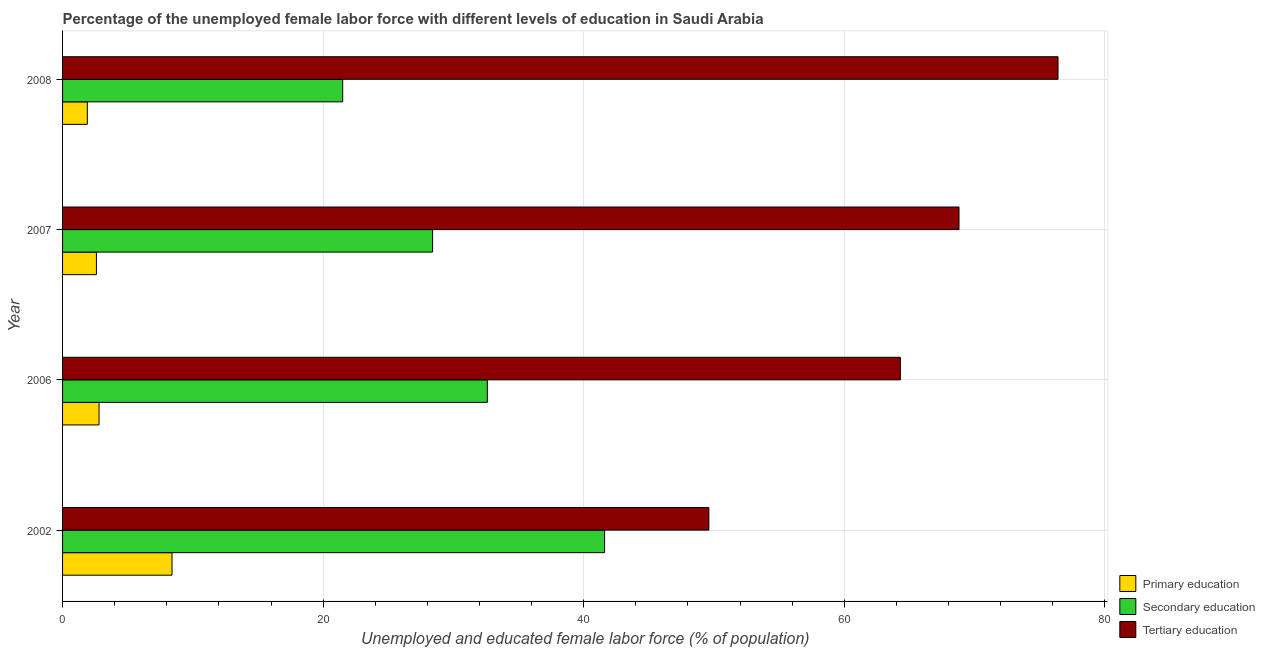How many different coloured bars are there?
Offer a terse response. 3. Are the number of bars on each tick of the Y-axis equal?
Your response must be concise. Yes. How many bars are there on the 2nd tick from the bottom?
Provide a succinct answer. 3. In how many cases, is the number of bars for a given year not equal to the number of legend labels?
Offer a terse response. 0. What is the percentage of female labor force who received tertiary education in 2002?
Your answer should be compact. 49.6. Across all years, what is the maximum percentage of female labor force who received primary education?
Your response must be concise. 8.4. Across all years, what is the minimum percentage of female labor force who received primary education?
Your answer should be very brief. 1.9. In which year was the percentage of female labor force who received primary education minimum?
Your answer should be compact. 2008. What is the total percentage of female labor force who received secondary education in the graph?
Ensure brevity in your answer.  124.1. What is the difference between the percentage of female labor force who received tertiary education in 2002 and that in 2006?
Ensure brevity in your answer.  -14.7. What is the difference between the percentage of female labor force who received secondary education in 2002 and the percentage of female labor force who received primary education in 2006?
Offer a terse response. 38.8. What is the average percentage of female labor force who received secondary education per year?
Give a very brief answer. 31.02. In the year 2006, what is the difference between the percentage of female labor force who received primary education and percentage of female labor force who received tertiary education?
Ensure brevity in your answer.  -61.5. In how many years, is the percentage of female labor force who received primary education greater than 8 %?
Offer a very short reply. 1. What is the ratio of the percentage of female labor force who received primary education in 2006 to that in 2007?
Give a very brief answer. 1.08. Is the percentage of female labor force who received secondary education in 2006 less than that in 2007?
Keep it short and to the point. No. What is the difference between the highest and the lowest percentage of female labor force who received secondary education?
Keep it short and to the point. 20.1. In how many years, is the percentage of female labor force who received primary education greater than the average percentage of female labor force who received primary education taken over all years?
Provide a succinct answer. 1. What does the 2nd bar from the top in 2002 represents?
Ensure brevity in your answer.  Secondary education. What does the 3rd bar from the bottom in 2006 represents?
Provide a succinct answer. Tertiary education. How many bars are there?
Your answer should be very brief. 12. What is the difference between two consecutive major ticks on the X-axis?
Ensure brevity in your answer.  20. Are the values on the major ticks of X-axis written in scientific E-notation?
Provide a succinct answer. No. Does the graph contain any zero values?
Ensure brevity in your answer.  No. What is the title of the graph?
Provide a short and direct response. Percentage of the unemployed female labor force with different levels of education in Saudi Arabia. What is the label or title of the X-axis?
Keep it short and to the point. Unemployed and educated female labor force (% of population). What is the Unemployed and educated female labor force (% of population) of Primary education in 2002?
Provide a short and direct response. 8.4. What is the Unemployed and educated female labor force (% of population) of Secondary education in 2002?
Offer a terse response. 41.6. What is the Unemployed and educated female labor force (% of population) of Tertiary education in 2002?
Provide a short and direct response. 49.6. What is the Unemployed and educated female labor force (% of population) in Primary education in 2006?
Keep it short and to the point. 2.8. What is the Unemployed and educated female labor force (% of population) of Secondary education in 2006?
Offer a terse response. 32.6. What is the Unemployed and educated female labor force (% of population) of Tertiary education in 2006?
Your answer should be compact. 64.3. What is the Unemployed and educated female labor force (% of population) in Primary education in 2007?
Give a very brief answer. 2.6. What is the Unemployed and educated female labor force (% of population) in Secondary education in 2007?
Your answer should be very brief. 28.4. What is the Unemployed and educated female labor force (% of population) of Tertiary education in 2007?
Ensure brevity in your answer.  68.8. What is the Unemployed and educated female labor force (% of population) of Primary education in 2008?
Offer a very short reply. 1.9. What is the Unemployed and educated female labor force (% of population) in Secondary education in 2008?
Your answer should be compact. 21.5. What is the Unemployed and educated female labor force (% of population) of Tertiary education in 2008?
Your answer should be compact. 76.4. Across all years, what is the maximum Unemployed and educated female labor force (% of population) in Primary education?
Keep it short and to the point. 8.4. Across all years, what is the maximum Unemployed and educated female labor force (% of population) in Secondary education?
Your answer should be compact. 41.6. Across all years, what is the maximum Unemployed and educated female labor force (% of population) of Tertiary education?
Offer a very short reply. 76.4. Across all years, what is the minimum Unemployed and educated female labor force (% of population) of Primary education?
Ensure brevity in your answer.  1.9. Across all years, what is the minimum Unemployed and educated female labor force (% of population) in Tertiary education?
Your response must be concise. 49.6. What is the total Unemployed and educated female labor force (% of population) of Primary education in the graph?
Your answer should be very brief. 15.7. What is the total Unemployed and educated female labor force (% of population) in Secondary education in the graph?
Your answer should be very brief. 124.1. What is the total Unemployed and educated female labor force (% of population) of Tertiary education in the graph?
Make the answer very short. 259.1. What is the difference between the Unemployed and educated female labor force (% of population) of Primary education in 2002 and that in 2006?
Give a very brief answer. 5.6. What is the difference between the Unemployed and educated female labor force (% of population) in Secondary education in 2002 and that in 2006?
Give a very brief answer. 9. What is the difference between the Unemployed and educated female labor force (% of population) of Tertiary education in 2002 and that in 2006?
Give a very brief answer. -14.7. What is the difference between the Unemployed and educated female labor force (% of population) in Primary education in 2002 and that in 2007?
Provide a succinct answer. 5.8. What is the difference between the Unemployed and educated female labor force (% of population) of Tertiary education in 2002 and that in 2007?
Give a very brief answer. -19.2. What is the difference between the Unemployed and educated female labor force (% of population) in Primary education in 2002 and that in 2008?
Ensure brevity in your answer.  6.5. What is the difference between the Unemployed and educated female labor force (% of population) of Secondary education in 2002 and that in 2008?
Your answer should be very brief. 20.1. What is the difference between the Unemployed and educated female labor force (% of population) of Tertiary education in 2002 and that in 2008?
Offer a very short reply. -26.8. What is the difference between the Unemployed and educated female labor force (% of population) of Secondary education in 2006 and that in 2007?
Ensure brevity in your answer.  4.2. What is the difference between the Unemployed and educated female labor force (% of population) in Primary education in 2006 and that in 2008?
Your response must be concise. 0.9. What is the difference between the Unemployed and educated female labor force (% of population) in Secondary education in 2006 and that in 2008?
Offer a terse response. 11.1. What is the difference between the Unemployed and educated female labor force (% of population) of Secondary education in 2007 and that in 2008?
Keep it short and to the point. 6.9. What is the difference between the Unemployed and educated female labor force (% of population) in Tertiary education in 2007 and that in 2008?
Keep it short and to the point. -7.6. What is the difference between the Unemployed and educated female labor force (% of population) of Primary education in 2002 and the Unemployed and educated female labor force (% of population) of Secondary education in 2006?
Offer a terse response. -24.2. What is the difference between the Unemployed and educated female labor force (% of population) in Primary education in 2002 and the Unemployed and educated female labor force (% of population) in Tertiary education in 2006?
Your answer should be very brief. -55.9. What is the difference between the Unemployed and educated female labor force (% of population) in Secondary education in 2002 and the Unemployed and educated female labor force (% of population) in Tertiary education in 2006?
Offer a very short reply. -22.7. What is the difference between the Unemployed and educated female labor force (% of population) in Primary education in 2002 and the Unemployed and educated female labor force (% of population) in Tertiary education in 2007?
Offer a very short reply. -60.4. What is the difference between the Unemployed and educated female labor force (% of population) of Secondary education in 2002 and the Unemployed and educated female labor force (% of population) of Tertiary education in 2007?
Provide a succinct answer. -27.2. What is the difference between the Unemployed and educated female labor force (% of population) in Primary education in 2002 and the Unemployed and educated female labor force (% of population) in Secondary education in 2008?
Offer a very short reply. -13.1. What is the difference between the Unemployed and educated female labor force (% of population) of Primary education in 2002 and the Unemployed and educated female labor force (% of population) of Tertiary education in 2008?
Your answer should be compact. -68. What is the difference between the Unemployed and educated female labor force (% of population) in Secondary education in 2002 and the Unemployed and educated female labor force (% of population) in Tertiary education in 2008?
Offer a terse response. -34.8. What is the difference between the Unemployed and educated female labor force (% of population) in Primary education in 2006 and the Unemployed and educated female labor force (% of population) in Secondary education in 2007?
Keep it short and to the point. -25.6. What is the difference between the Unemployed and educated female labor force (% of population) in Primary education in 2006 and the Unemployed and educated female labor force (% of population) in Tertiary education in 2007?
Keep it short and to the point. -66. What is the difference between the Unemployed and educated female labor force (% of population) of Secondary education in 2006 and the Unemployed and educated female labor force (% of population) of Tertiary education in 2007?
Ensure brevity in your answer.  -36.2. What is the difference between the Unemployed and educated female labor force (% of population) in Primary education in 2006 and the Unemployed and educated female labor force (% of population) in Secondary education in 2008?
Offer a very short reply. -18.7. What is the difference between the Unemployed and educated female labor force (% of population) in Primary education in 2006 and the Unemployed and educated female labor force (% of population) in Tertiary education in 2008?
Your response must be concise. -73.6. What is the difference between the Unemployed and educated female labor force (% of population) of Secondary education in 2006 and the Unemployed and educated female labor force (% of population) of Tertiary education in 2008?
Keep it short and to the point. -43.8. What is the difference between the Unemployed and educated female labor force (% of population) of Primary education in 2007 and the Unemployed and educated female labor force (% of population) of Secondary education in 2008?
Offer a very short reply. -18.9. What is the difference between the Unemployed and educated female labor force (% of population) of Primary education in 2007 and the Unemployed and educated female labor force (% of population) of Tertiary education in 2008?
Ensure brevity in your answer.  -73.8. What is the difference between the Unemployed and educated female labor force (% of population) in Secondary education in 2007 and the Unemployed and educated female labor force (% of population) in Tertiary education in 2008?
Make the answer very short. -48. What is the average Unemployed and educated female labor force (% of population) of Primary education per year?
Make the answer very short. 3.92. What is the average Unemployed and educated female labor force (% of population) of Secondary education per year?
Provide a succinct answer. 31.02. What is the average Unemployed and educated female labor force (% of population) in Tertiary education per year?
Give a very brief answer. 64.78. In the year 2002, what is the difference between the Unemployed and educated female labor force (% of population) in Primary education and Unemployed and educated female labor force (% of population) in Secondary education?
Make the answer very short. -33.2. In the year 2002, what is the difference between the Unemployed and educated female labor force (% of population) in Primary education and Unemployed and educated female labor force (% of population) in Tertiary education?
Offer a terse response. -41.2. In the year 2006, what is the difference between the Unemployed and educated female labor force (% of population) of Primary education and Unemployed and educated female labor force (% of population) of Secondary education?
Your answer should be very brief. -29.8. In the year 2006, what is the difference between the Unemployed and educated female labor force (% of population) of Primary education and Unemployed and educated female labor force (% of population) of Tertiary education?
Ensure brevity in your answer.  -61.5. In the year 2006, what is the difference between the Unemployed and educated female labor force (% of population) in Secondary education and Unemployed and educated female labor force (% of population) in Tertiary education?
Provide a short and direct response. -31.7. In the year 2007, what is the difference between the Unemployed and educated female labor force (% of population) of Primary education and Unemployed and educated female labor force (% of population) of Secondary education?
Your response must be concise. -25.8. In the year 2007, what is the difference between the Unemployed and educated female labor force (% of population) in Primary education and Unemployed and educated female labor force (% of population) in Tertiary education?
Your response must be concise. -66.2. In the year 2007, what is the difference between the Unemployed and educated female labor force (% of population) of Secondary education and Unemployed and educated female labor force (% of population) of Tertiary education?
Your answer should be compact. -40.4. In the year 2008, what is the difference between the Unemployed and educated female labor force (% of population) of Primary education and Unemployed and educated female labor force (% of population) of Secondary education?
Your answer should be compact. -19.6. In the year 2008, what is the difference between the Unemployed and educated female labor force (% of population) of Primary education and Unemployed and educated female labor force (% of population) of Tertiary education?
Provide a short and direct response. -74.5. In the year 2008, what is the difference between the Unemployed and educated female labor force (% of population) of Secondary education and Unemployed and educated female labor force (% of population) of Tertiary education?
Ensure brevity in your answer.  -54.9. What is the ratio of the Unemployed and educated female labor force (% of population) in Primary education in 2002 to that in 2006?
Your answer should be compact. 3. What is the ratio of the Unemployed and educated female labor force (% of population) in Secondary education in 2002 to that in 2006?
Make the answer very short. 1.28. What is the ratio of the Unemployed and educated female labor force (% of population) of Tertiary education in 2002 to that in 2006?
Offer a terse response. 0.77. What is the ratio of the Unemployed and educated female labor force (% of population) of Primary education in 2002 to that in 2007?
Give a very brief answer. 3.23. What is the ratio of the Unemployed and educated female labor force (% of population) in Secondary education in 2002 to that in 2007?
Give a very brief answer. 1.46. What is the ratio of the Unemployed and educated female labor force (% of population) in Tertiary education in 2002 to that in 2007?
Your answer should be very brief. 0.72. What is the ratio of the Unemployed and educated female labor force (% of population) of Primary education in 2002 to that in 2008?
Make the answer very short. 4.42. What is the ratio of the Unemployed and educated female labor force (% of population) in Secondary education in 2002 to that in 2008?
Provide a short and direct response. 1.93. What is the ratio of the Unemployed and educated female labor force (% of population) in Tertiary education in 2002 to that in 2008?
Ensure brevity in your answer.  0.65. What is the ratio of the Unemployed and educated female labor force (% of population) in Primary education in 2006 to that in 2007?
Ensure brevity in your answer.  1.08. What is the ratio of the Unemployed and educated female labor force (% of population) of Secondary education in 2006 to that in 2007?
Offer a terse response. 1.15. What is the ratio of the Unemployed and educated female labor force (% of population) in Tertiary education in 2006 to that in 2007?
Offer a very short reply. 0.93. What is the ratio of the Unemployed and educated female labor force (% of population) in Primary education in 2006 to that in 2008?
Offer a very short reply. 1.47. What is the ratio of the Unemployed and educated female labor force (% of population) of Secondary education in 2006 to that in 2008?
Provide a succinct answer. 1.52. What is the ratio of the Unemployed and educated female labor force (% of population) in Tertiary education in 2006 to that in 2008?
Offer a very short reply. 0.84. What is the ratio of the Unemployed and educated female labor force (% of population) in Primary education in 2007 to that in 2008?
Your answer should be very brief. 1.37. What is the ratio of the Unemployed and educated female labor force (% of population) of Secondary education in 2007 to that in 2008?
Provide a short and direct response. 1.32. What is the ratio of the Unemployed and educated female labor force (% of population) in Tertiary education in 2007 to that in 2008?
Your answer should be very brief. 0.9. What is the difference between the highest and the second highest Unemployed and educated female labor force (% of population) in Primary education?
Offer a very short reply. 5.6. What is the difference between the highest and the second highest Unemployed and educated female labor force (% of population) in Secondary education?
Your response must be concise. 9. What is the difference between the highest and the lowest Unemployed and educated female labor force (% of population) of Secondary education?
Provide a succinct answer. 20.1. What is the difference between the highest and the lowest Unemployed and educated female labor force (% of population) of Tertiary education?
Ensure brevity in your answer.  26.8. 